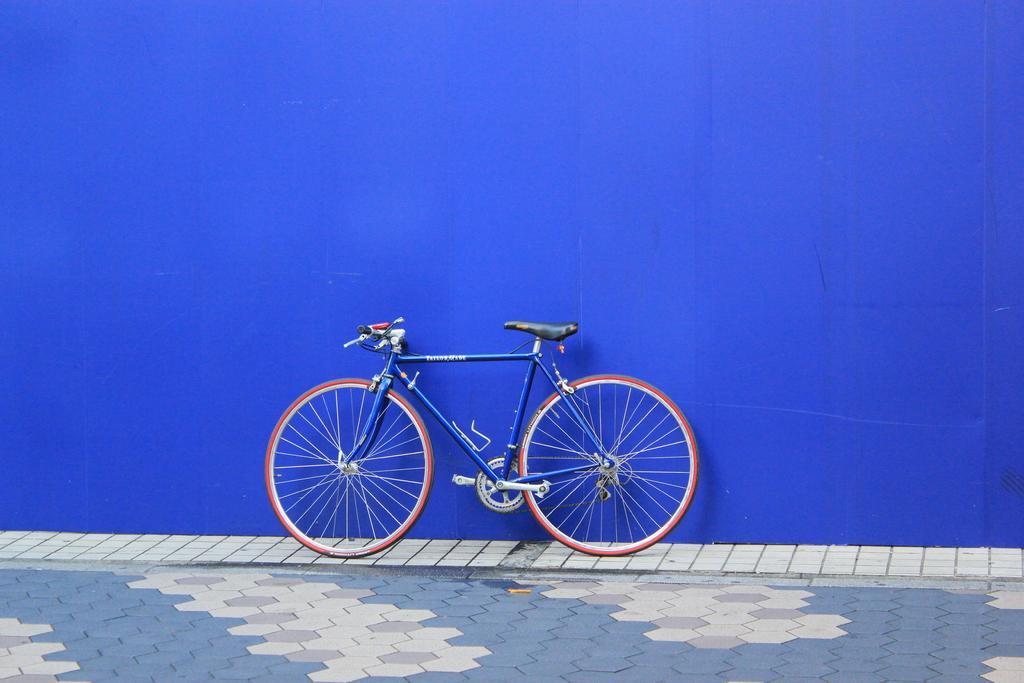Describe this image in one or two sentences. In this picture we can see a bicycle, in the background there is a blue color wall, at the bottom there are some tiles. 